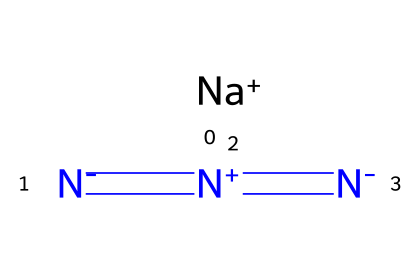What is the chemical name of the compound represented? The SMILES representation shows the presence of sodium (Na) and the azide group ([N-]=[N+]=[N-]), indicating that the compound is sodium azide.
Answer: sodium azide How many nitrogen atoms are in sodium azide? By analyzing the SMILES, we see three nitrogen atoms (N) in the azide group ([N-]=[N+]=[N-]) and one sodium atom, making a total of three nitrogen atoms.
Answer: three What type of ions are present in sodium azide? The SMILES notation indicates the presence of a sodium ion ([Na+]) and a neutral azide group, meaning the compound consists of a positive ion (sodium) and a neutral molecule (azide).
Answer: sodium ion and azide What is the formal charge on the nitrogen atoms in the azide group? In the azide group, the first nitrogen ([N-]) has a formal charge of negative one, the second nitrogen ([N+]) has a formal charge of positive one, and the last nitrogen ([N-]) is neutral, leading to an overall neutral azide group.
Answer: -1, +1, -1 How does sodium azide behave when heated? Sodium azide decomposes when heated, producing nitrogen gas and sodium metal, which is characteristic of azides as they tend to release nitrogen upon decomposition.
Answer: produces nitrogen gas What is the oxidation state of sodium in sodium azide? Sodium typically exhibits a +1 oxidation state as an alkali metal, and in sodium azide, it maintains this state, confirming the oxidation state is +1.
Answer: +1 